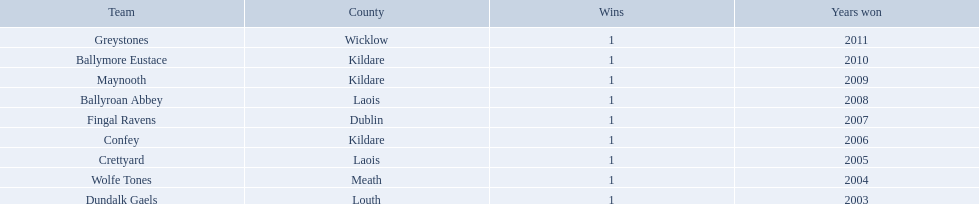What county is ballymore eustace from? Kildare. Besides convey, which other team is from the same county? Maynooth. In which county is ballymore eustace located? Kildare. Apart from convey, what other team originates from the same county? Maynooth. From which county is the squad that was victorious in 2009? Kildare. What is the name of the team? Maynooth. What is the location of ballymore eustace? Kildare. Which other teams besides ballymore eustace originate from kildare? Maynooth, Confey. In the 2009 match between maynooth and confey, who emerged victorious? Maynooth. 